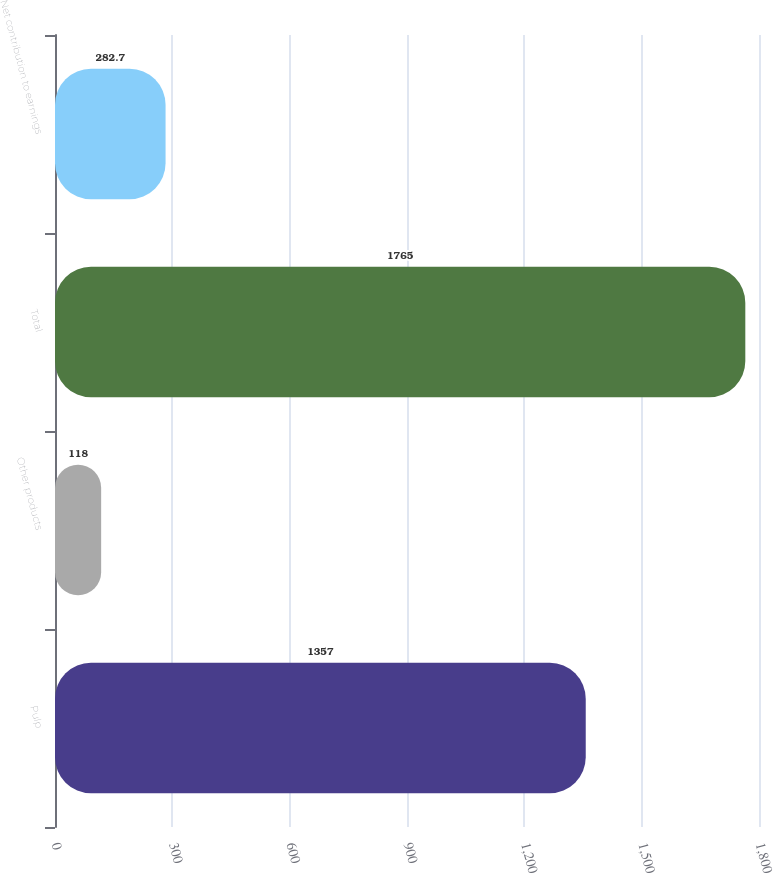Convert chart to OTSL. <chart><loc_0><loc_0><loc_500><loc_500><bar_chart><fcel>Pulp<fcel>Other products<fcel>Total<fcel>Net contribution to earnings<nl><fcel>1357<fcel>118<fcel>1765<fcel>282.7<nl></chart> 